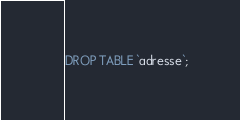Convert code to text. <code><loc_0><loc_0><loc_500><loc_500><_SQL_>DROP TABLE `adresse`;
</code> 